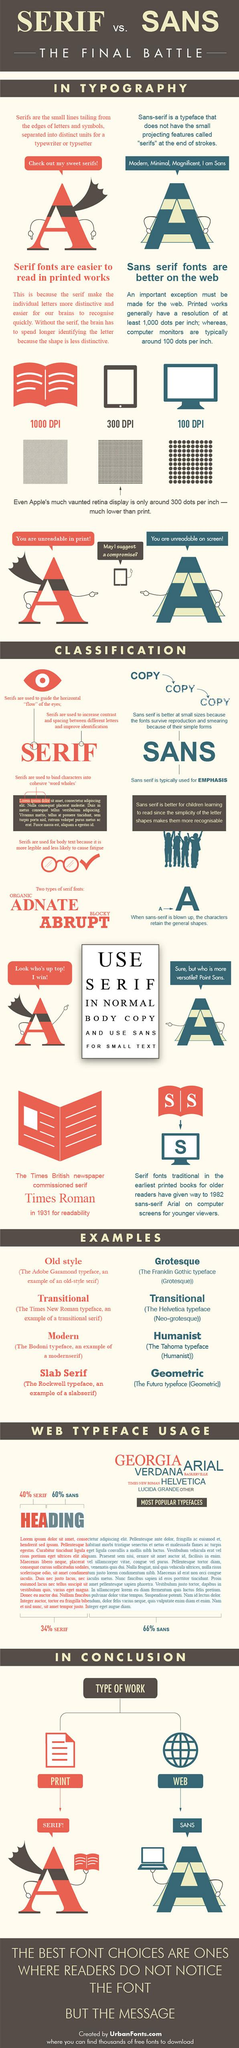List a handful of essential elements in this visual. The most commonly used font for headings on web pages is sans-serif. Based on this information, there are 1000 dots in an inch in a printed medium. The serif font known as Times Roman was introduced in 1932. There are 100 dots per inch on a computer screen. The most popular sans-serif font used in web design is Arial. 